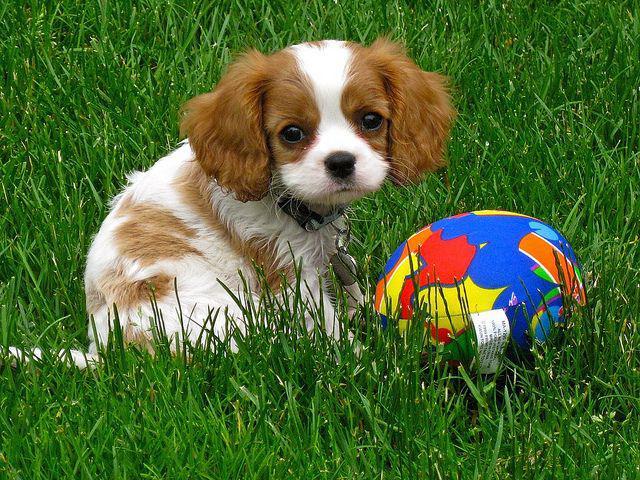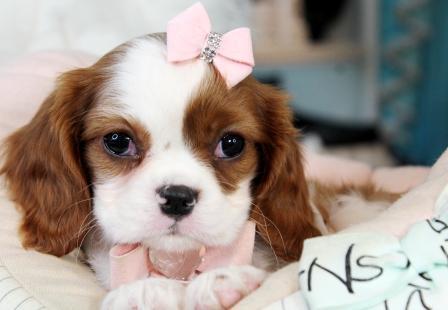The first image is the image on the left, the second image is the image on the right. Analyze the images presented: Is the assertion "There are exactly two animals in the image on the left." valid? Answer yes or no. No. 